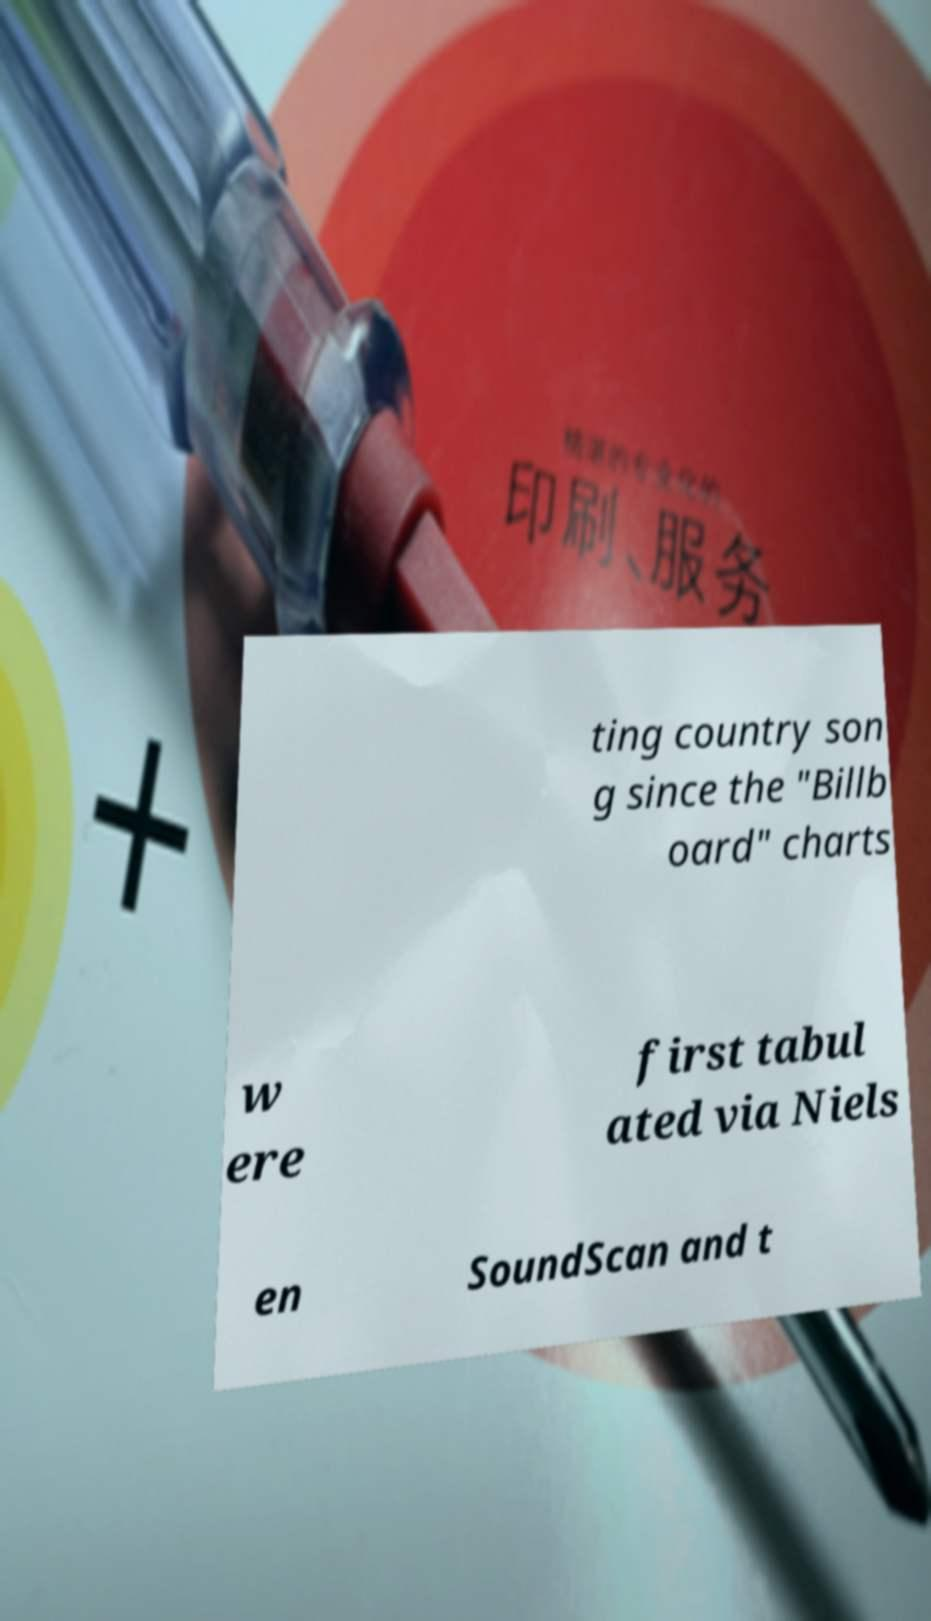Please read and relay the text visible in this image. What does it say? ting country son g since the "Billb oard" charts w ere first tabul ated via Niels en SoundScan and t 